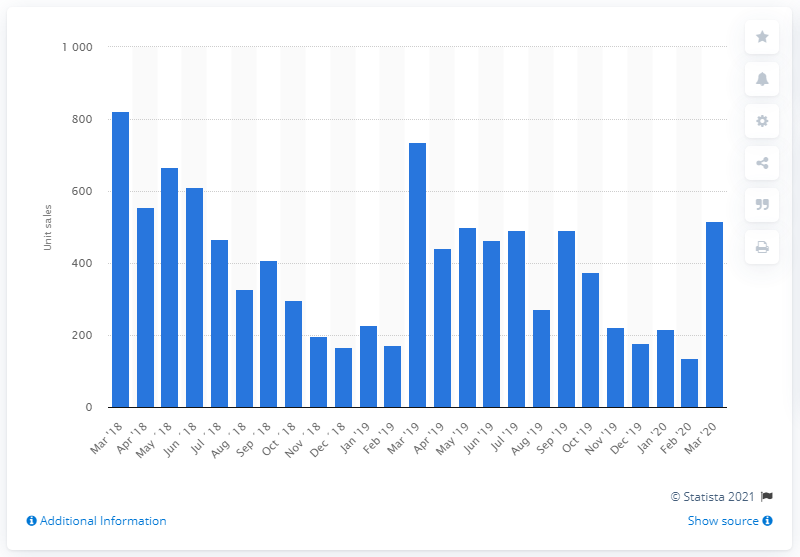Point out several critical features in this image. In March of 2019, a total of 516 Harley-Davidson motorcycles were sold in the UK. 